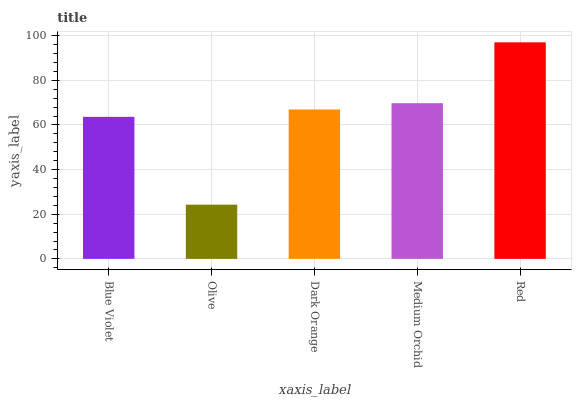Is Olive the minimum?
Answer yes or no. Yes. Is Red the maximum?
Answer yes or no. Yes. Is Dark Orange the minimum?
Answer yes or no. No. Is Dark Orange the maximum?
Answer yes or no. No. Is Dark Orange greater than Olive?
Answer yes or no. Yes. Is Olive less than Dark Orange?
Answer yes or no. Yes. Is Olive greater than Dark Orange?
Answer yes or no. No. Is Dark Orange less than Olive?
Answer yes or no. No. Is Dark Orange the high median?
Answer yes or no. Yes. Is Dark Orange the low median?
Answer yes or no. Yes. Is Medium Orchid the high median?
Answer yes or no. No. Is Olive the low median?
Answer yes or no. No. 